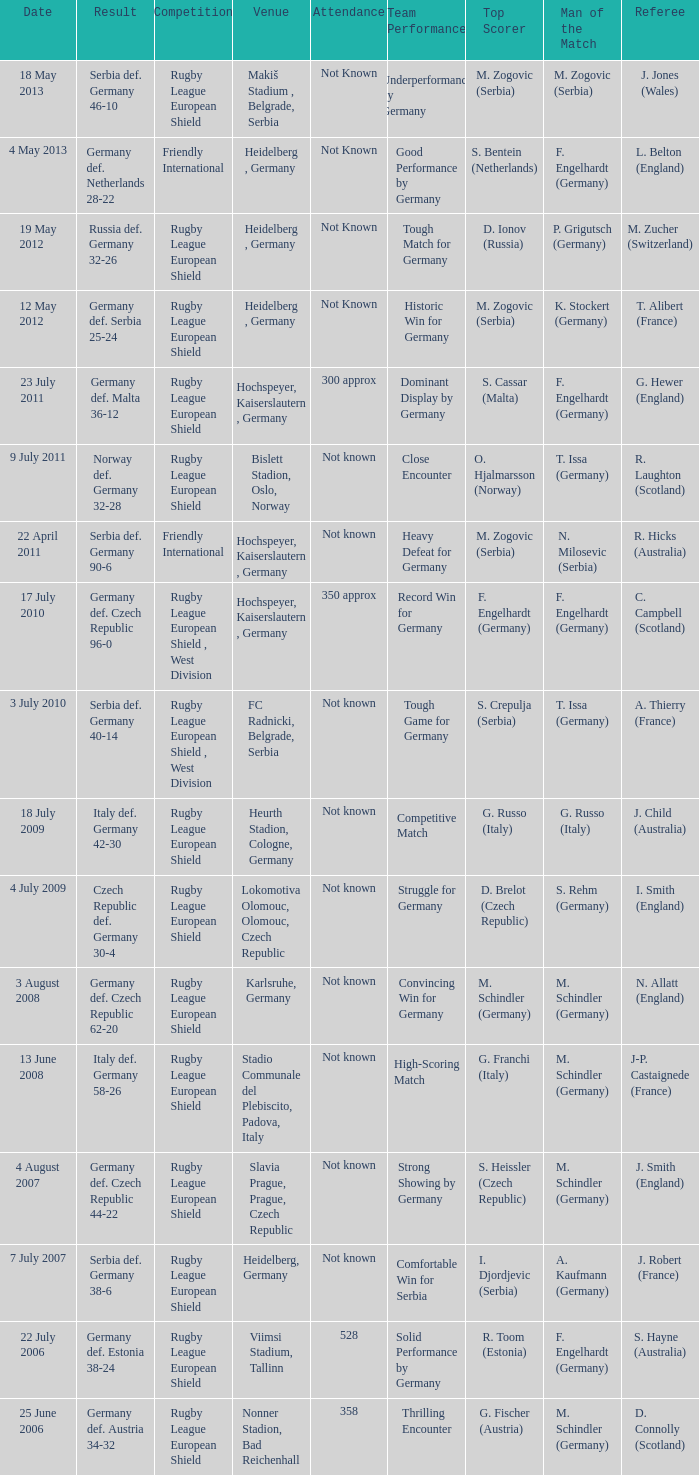For the game with 528 attendance, what was the result? Germany def. Estonia 38-24. 